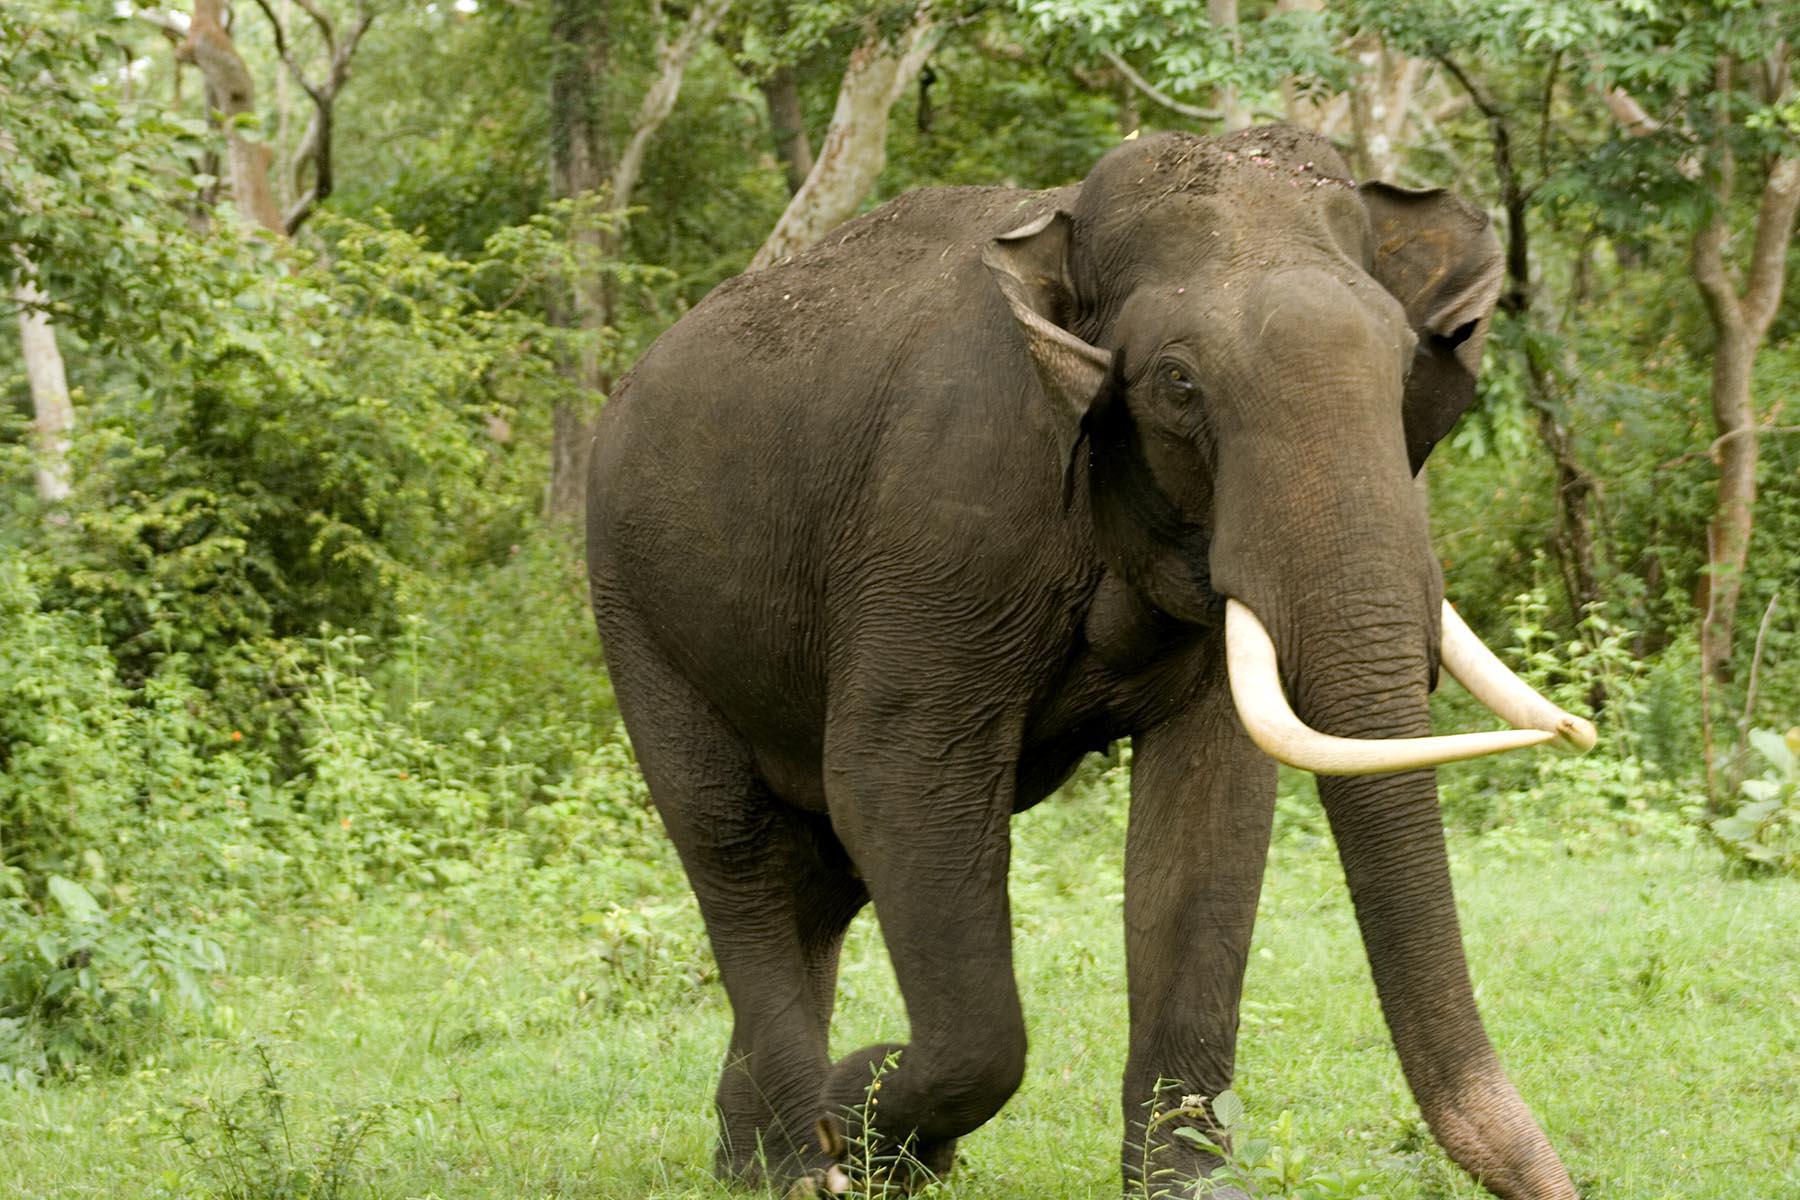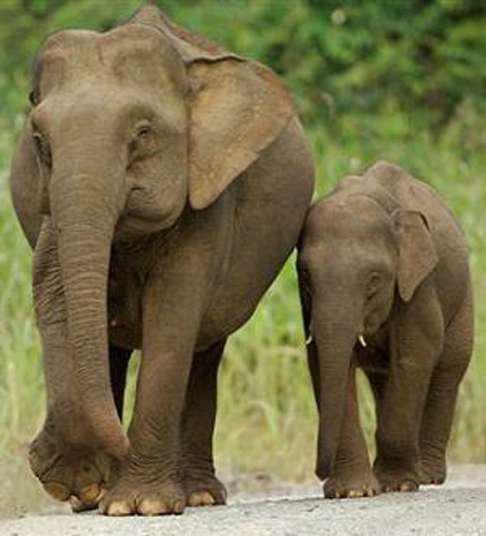The first image is the image on the left, the second image is the image on the right. Examine the images to the left and right. Is the description "A body of water is visible in one of the images." accurate? Answer yes or no. No. The first image is the image on the left, the second image is the image on the right. Analyze the images presented: Is the assertion "In one image, an elephant is in or near water." valid? Answer yes or no. No. The first image is the image on the left, the second image is the image on the right. Analyze the images presented: Is the assertion "There are two elephants fully visible in the picture on the right" valid? Answer yes or no. Yes. 